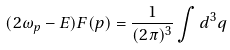<formula> <loc_0><loc_0><loc_500><loc_500>( 2 \omega _ { p } - E ) F ( p ) = \frac { 1 } { ( 2 \pi ) ^ { 3 } } \int d ^ { 3 } q</formula> 